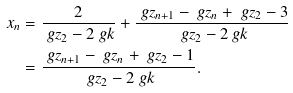<formula> <loc_0><loc_0><loc_500><loc_500>x _ { n } & = \frac { 2 } { \ g z _ { 2 } - 2 \ g k } + \frac { \ g z _ { n + 1 } - \ g z _ { n } + \ g z _ { 2 } - 3 } { \ g z _ { 2 } - 2 \ g k } \\ & = \frac { \ g z _ { n + 1 } - \ g z _ { n } + \ g z _ { 2 } - 1 } { \ g z _ { 2 } - 2 \ g k } .</formula> 